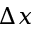Convert formula to latex. <formula><loc_0><loc_0><loc_500><loc_500>\Delta x</formula> 